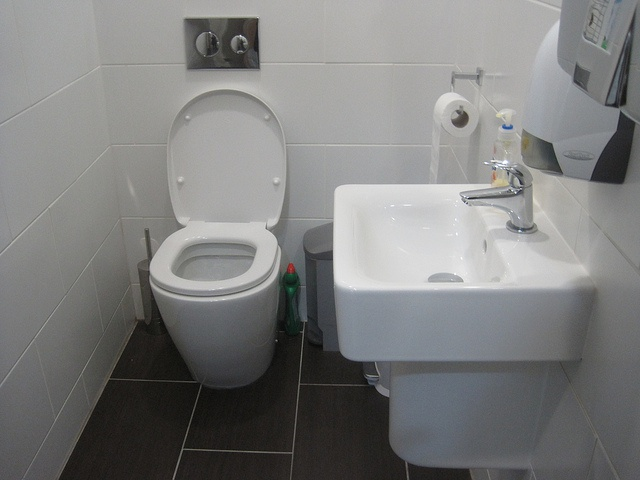Describe the objects in this image and their specific colors. I can see sink in darkgray, lightgray, and gray tones, toilet in darkgray, gray, black, and lightgray tones, bottle in darkgray, lightgray, and tan tones, and bottle in darkgray, black, darkgreen, brown, and gray tones in this image. 